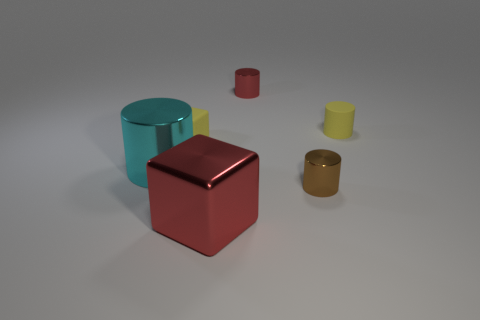The object that is the same color as the shiny cube is what size?
Provide a short and direct response. Small. Do the cyan object and the rubber cylinder have the same size?
Your response must be concise. No. What number of things are either metallic cylinders that are on the left side of the big block or big cyan objects left of the small yellow matte cylinder?
Offer a very short reply. 1. What is the material of the small yellow object on the left side of the red object that is in front of the small block?
Offer a terse response. Rubber. What number of other things are made of the same material as the tiny red cylinder?
Ensure brevity in your answer.  3. Do the large cyan thing and the large red object have the same shape?
Keep it short and to the point. No. There is a red metal thing that is in front of the big cyan metallic cylinder; how big is it?
Provide a short and direct response. Large. There is a yellow matte cube; is it the same size as the rubber object to the right of the small red metallic cylinder?
Your answer should be compact. Yes. Is the number of cyan things that are on the right side of the red shiny cylinder less than the number of matte blocks?
Provide a short and direct response. Yes. There is a cyan thing that is the same shape as the brown metallic object; what is its material?
Keep it short and to the point. Metal. 